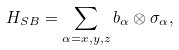Convert formula to latex. <formula><loc_0><loc_0><loc_500><loc_500>H _ { S B } = \sum _ { \alpha = x , y , z } b _ { \alpha } \otimes \sigma _ { \alpha } ,</formula> 